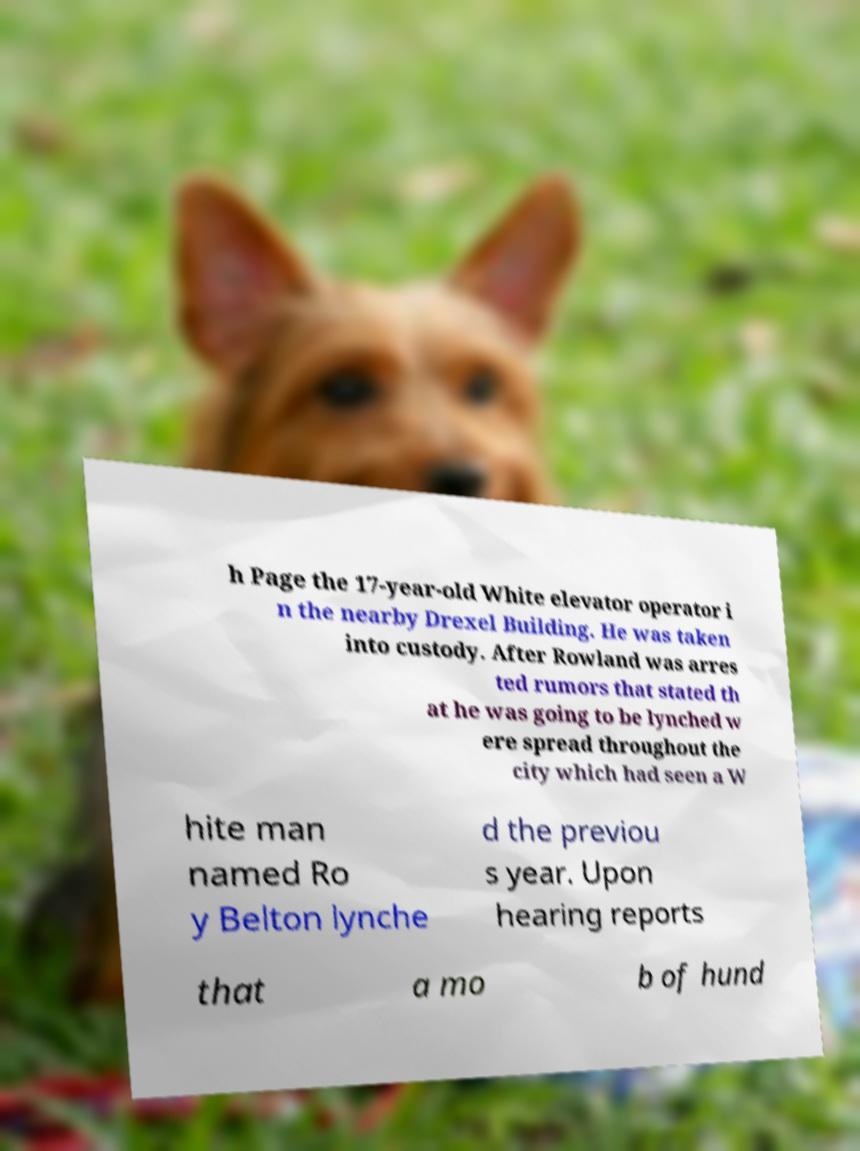Please identify and transcribe the text found in this image. h Page the 17-year-old White elevator operator i n the nearby Drexel Building. He was taken into custody. After Rowland was arres ted rumors that stated th at he was going to be lynched w ere spread throughout the city which had seen a W hite man named Ro y Belton lynche d the previou s year. Upon hearing reports that a mo b of hund 